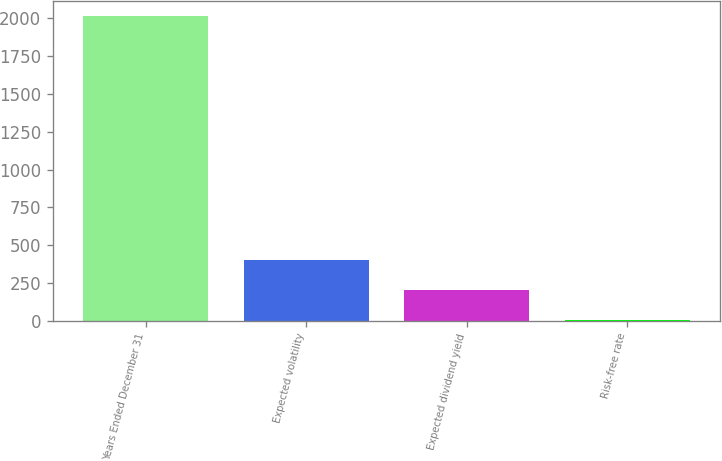Convert chart to OTSL. <chart><loc_0><loc_0><loc_500><loc_500><bar_chart><fcel>Years Ended December 31<fcel>Expected volatility<fcel>Expected dividend yield<fcel>Risk-free rate<nl><fcel>2016<fcel>404<fcel>202.5<fcel>1<nl></chart> 